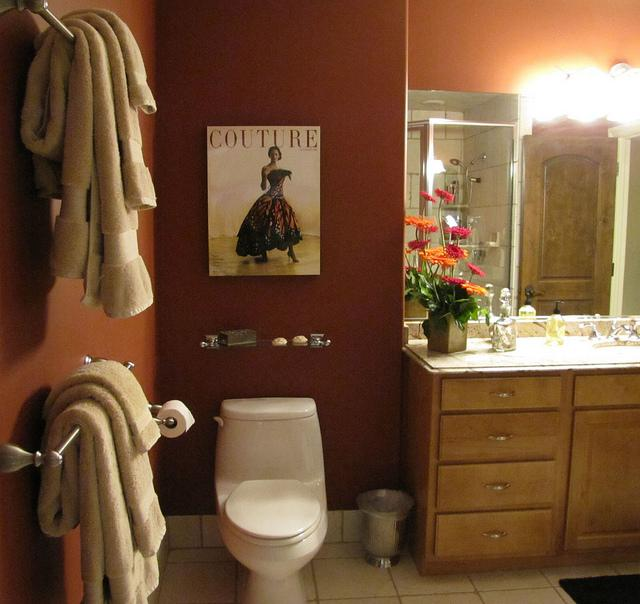What athlete's last name appears on the poster? couture 